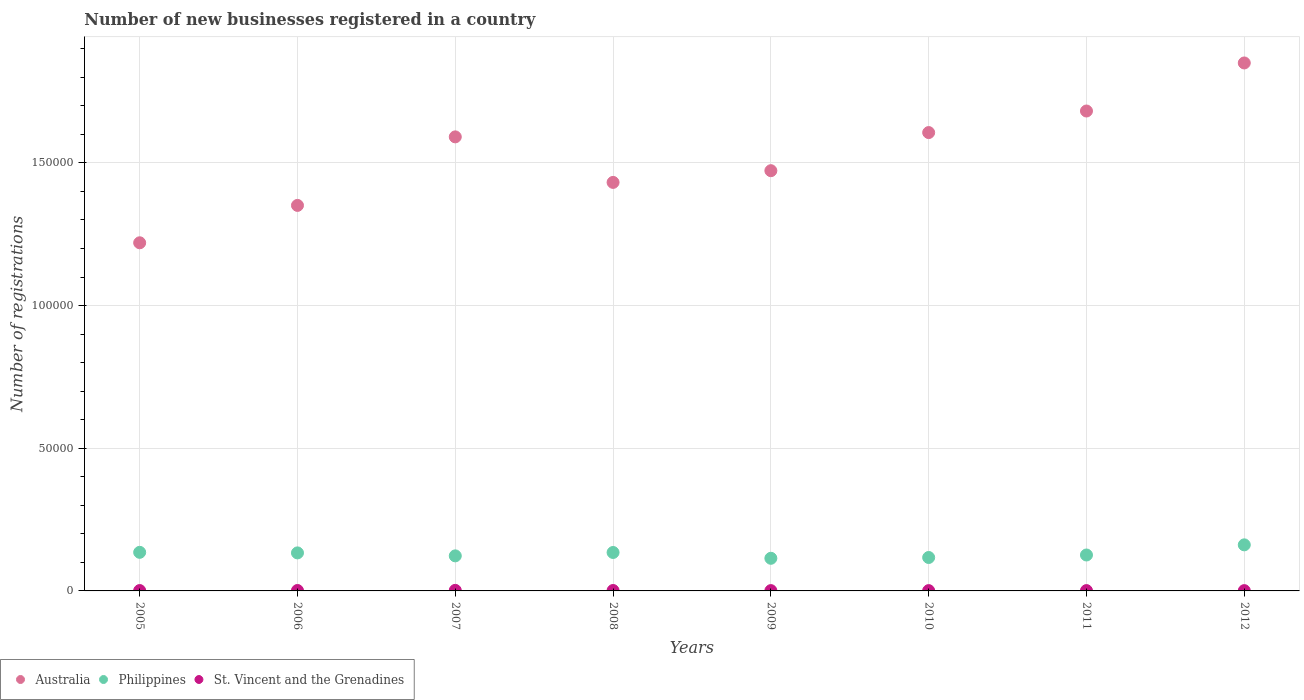What is the number of new businesses registered in Philippines in 2009?
Offer a very short reply. 1.14e+04. Across all years, what is the maximum number of new businesses registered in St. Vincent and the Grenadines?
Provide a succinct answer. 196. Across all years, what is the minimum number of new businesses registered in Australia?
Your answer should be very brief. 1.22e+05. What is the total number of new businesses registered in St. Vincent and the Grenadines in the graph?
Keep it short and to the point. 1047. What is the difference between the number of new businesses registered in St. Vincent and the Grenadines in 2005 and that in 2007?
Keep it short and to the point. -69. What is the difference between the number of new businesses registered in St. Vincent and the Grenadines in 2007 and the number of new businesses registered in Australia in 2012?
Give a very brief answer. -1.85e+05. What is the average number of new businesses registered in Philippines per year?
Your answer should be very brief. 1.31e+04. In the year 2012, what is the difference between the number of new businesses registered in St. Vincent and the Grenadines and number of new businesses registered in Australia?
Your answer should be very brief. -1.85e+05. In how many years, is the number of new businesses registered in Australia greater than 90000?
Ensure brevity in your answer.  8. What is the ratio of the number of new businesses registered in Philippines in 2005 to that in 2012?
Provide a succinct answer. 0.84. Is the number of new businesses registered in St. Vincent and the Grenadines in 2007 less than that in 2012?
Your answer should be very brief. No. What is the difference between the highest and the second highest number of new businesses registered in Australia?
Offer a terse response. 1.68e+04. What is the difference between the highest and the lowest number of new businesses registered in Australia?
Your answer should be compact. 6.30e+04. Is it the case that in every year, the sum of the number of new businesses registered in St. Vincent and the Grenadines and number of new businesses registered in Philippines  is greater than the number of new businesses registered in Australia?
Provide a succinct answer. No. Does the number of new businesses registered in St. Vincent and the Grenadines monotonically increase over the years?
Offer a terse response. No. How many years are there in the graph?
Offer a very short reply. 8. What is the difference between two consecutive major ticks on the Y-axis?
Ensure brevity in your answer.  5.00e+04. How many legend labels are there?
Offer a terse response. 3. How are the legend labels stacked?
Your answer should be very brief. Horizontal. What is the title of the graph?
Your answer should be very brief. Number of new businesses registered in a country. Does "Bangladesh" appear as one of the legend labels in the graph?
Make the answer very short. No. What is the label or title of the Y-axis?
Your answer should be compact. Number of registrations. What is the Number of registrations of Australia in 2005?
Your answer should be compact. 1.22e+05. What is the Number of registrations of Philippines in 2005?
Keep it short and to the point. 1.35e+04. What is the Number of registrations of St. Vincent and the Grenadines in 2005?
Keep it short and to the point. 127. What is the Number of registrations of Australia in 2006?
Give a very brief answer. 1.35e+05. What is the Number of registrations of Philippines in 2006?
Keep it short and to the point. 1.33e+04. What is the Number of registrations in St. Vincent and the Grenadines in 2006?
Make the answer very short. 149. What is the Number of registrations of Australia in 2007?
Your response must be concise. 1.59e+05. What is the Number of registrations in Philippines in 2007?
Provide a succinct answer. 1.23e+04. What is the Number of registrations of St. Vincent and the Grenadines in 2007?
Your response must be concise. 196. What is the Number of registrations in Australia in 2008?
Your answer should be very brief. 1.43e+05. What is the Number of registrations of Philippines in 2008?
Your answer should be very brief. 1.35e+04. What is the Number of registrations of St. Vincent and the Grenadines in 2008?
Your response must be concise. 145. What is the Number of registrations of Australia in 2009?
Your answer should be very brief. 1.47e+05. What is the Number of registrations in Philippines in 2009?
Give a very brief answer. 1.14e+04. What is the Number of registrations in St. Vincent and the Grenadines in 2009?
Provide a short and direct response. 109. What is the Number of registrations of Australia in 2010?
Your answer should be compact. 1.61e+05. What is the Number of registrations of Philippines in 2010?
Provide a short and direct response. 1.17e+04. What is the Number of registrations of St. Vincent and the Grenadines in 2010?
Your answer should be compact. 105. What is the Number of registrations of Australia in 2011?
Offer a terse response. 1.68e+05. What is the Number of registrations of Philippines in 2011?
Give a very brief answer. 1.26e+04. What is the Number of registrations of St. Vincent and the Grenadines in 2011?
Your answer should be compact. 115. What is the Number of registrations of Australia in 2012?
Provide a short and direct response. 1.85e+05. What is the Number of registrations of Philippines in 2012?
Make the answer very short. 1.61e+04. What is the Number of registrations in St. Vincent and the Grenadines in 2012?
Offer a terse response. 101. Across all years, what is the maximum Number of registrations of Australia?
Keep it short and to the point. 1.85e+05. Across all years, what is the maximum Number of registrations of Philippines?
Your response must be concise. 1.61e+04. Across all years, what is the maximum Number of registrations of St. Vincent and the Grenadines?
Your response must be concise. 196. Across all years, what is the minimum Number of registrations of Australia?
Offer a very short reply. 1.22e+05. Across all years, what is the minimum Number of registrations in Philippines?
Provide a short and direct response. 1.14e+04. Across all years, what is the minimum Number of registrations in St. Vincent and the Grenadines?
Your response must be concise. 101. What is the total Number of registrations of Australia in the graph?
Your answer should be compact. 1.22e+06. What is the total Number of registrations of Philippines in the graph?
Ensure brevity in your answer.  1.04e+05. What is the total Number of registrations in St. Vincent and the Grenadines in the graph?
Give a very brief answer. 1047. What is the difference between the Number of registrations of Australia in 2005 and that in 2006?
Your response must be concise. -1.31e+04. What is the difference between the Number of registrations of Philippines in 2005 and that in 2006?
Ensure brevity in your answer.  198. What is the difference between the Number of registrations of Australia in 2005 and that in 2007?
Provide a short and direct response. -3.71e+04. What is the difference between the Number of registrations in Philippines in 2005 and that in 2007?
Make the answer very short. 1238. What is the difference between the Number of registrations of St. Vincent and the Grenadines in 2005 and that in 2007?
Provide a short and direct response. -69. What is the difference between the Number of registrations in Australia in 2005 and that in 2008?
Your answer should be compact. -2.12e+04. What is the difference between the Number of registrations of Australia in 2005 and that in 2009?
Provide a short and direct response. -2.53e+04. What is the difference between the Number of registrations of Philippines in 2005 and that in 2009?
Provide a short and direct response. 2088. What is the difference between the Number of registrations of St. Vincent and the Grenadines in 2005 and that in 2009?
Your response must be concise. 18. What is the difference between the Number of registrations in Australia in 2005 and that in 2010?
Your answer should be compact. -3.86e+04. What is the difference between the Number of registrations in Philippines in 2005 and that in 2010?
Offer a very short reply. 1809. What is the difference between the Number of registrations in St. Vincent and the Grenadines in 2005 and that in 2010?
Keep it short and to the point. 22. What is the difference between the Number of registrations in Australia in 2005 and that in 2011?
Provide a succinct answer. -4.62e+04. What is the difference between the Number of registrations of Philippines in 2005 and that in 2011?
Offer a very short reply. 933. What is the difference between the Number of registrations in St. Vincent and the Grenadines in 2005 and that in 2011?
Keep it short and to the point. 12. What is the difference between the Number of registrations in Australia in 2005 and that in 2012?
Offer a terse response. -6.30e+04. What is the difference between the Number of registrations in Philippines in 2005 and that in 2012?
Provide a short and direct response. -2620. What is the difference between the Number of registrations of Australia in 2006 and that in 2007?
Ensure brevity in your answer.  -2.40e+04. What is the difference between the Number of registrations in Philippines in 2006 and that in 2007?
Ensure brevity in your answer.  1040. What is the difference between the Number of registrations of St. Vincent and the Grenadines in 2006 and that in 2007?
Your response must be concise. -47. What is the difference between the Number of registrations of Australia in 2006 and that in 2008?
Provide a succinct answer. -8061. What is the difference between the Number of registrations of Philippines in 2006 and that in 2008?
Ensure brevity in your answer.  -145. What is the difference between the Number of registrations in Australia in 2006 and that in 2009?
Provide a short and direct response. -1.22e+04. What is the difference between the Number of registrations of Philippines in 2006 and that in 2009?
Give a very brief answer. 1890. What is the difference between the Number of registrations of Australia in 2006 and that in 2010?
Your answer should be very brief. -2.55e+04. What is the difference between the Number of registrations in Philippines in 2006 and that in 2010?
Your answer should be very brief. 1611. What is the difference between the Number of registrations of St. Vincent and the Grenadines in 2006 and that in 2010?
Your response must be concise. 44. What is the difference between the Number of registrations of Australia in 2006 and that in 2011?
Give a very brief answer. -3.31e+04. What is the difference between the Number of registrations in Philippines in 2006 and that in 2011?
Your response must be concise. 735. What is the difference between the Number of registrations of Australia in 2006 and that in 2012?
Offer a very short reply. -4.99e+04. What is the difference between the Number of registrations in Philippines in 2006 and that in 2012?
Make the answer very short. -2818. What is the difference between the Number of registrations in Australia in 2007 and that in 2008?
Ensure brevity in your answer.  1.60e+04. What is the difference between the Number of registrations in Philippines in 2007 and that in 2008?
Make the answer very short. -1185. What is the difference between the Number of registrations of St. Vincent and the Grenadines in 2007 and that in 2008?
Give a very brief answer. 51. What is the difference between the Number of registrations of Australia in 2007 and that in 2009?
Provide a succinct answer. 1.18e+04. What is the difference between the Number of registrations in Philippines in 2007 and that in 2009?
Make the answer very short. 850. What is the difference between the Number of registrations of St. Vincent and the Grenadines in 2007 and that in 2009?
Provide a short and direct response. 87. What is the difference between the Number of registrations of Australia in 2007 and that in 2010?
Give a very brief answer. -1507. What is the difference between the Number of registrations of Philippines in 2007 and that in 2010?
Offer a very short reply. 571. What is the difference between the Number of registrations of St. Vincent and the Grenadines in 2007 and that in 2010?
Your answer should be very brief. 91. What is the difference between the Number of registrations in Australia in 2007 and that in 2011?
Provide a succinct answer. -9062. What is the difference between the Number of registrations of Philippines in 2007 and that in 2011?
Your response must be concise. -305. What is the difference between the Number of registrations of Australia in 2007 and that in 2012?
Offer a very short reply. -2.59e+04. What is the difference between the Number of registrations of Philippines in 2007 and that in 2012?
Provide a succinct answer. -3858. What is the difference between the Number of registrations in St. Vincent and the Grenadines in 2007 and that in 2012?
Your answer should be compact. 95. What is the difference between the Number of registrations in Australia in 2008 and that in 2009?
Your answer should be compact. -4105. What is the difference between the Number of registrations of Philippines in 2008 and that in 2009?
Offer a very short reply. 2035. What is the difference between the Number of registrations in Australia in 2008 and that in 2010?
Ensure brevity in your answer.  -1.75e+04. What is the difference between the Number of registrations in Philippines in 2008 and that in 2010?
Offer a terse response. 1756. What is the difference between the Number of registrations of Australia in 2008 and that in 2011?
Provide a short and direct response. -2.50e+04. What is the difference between the Number of registrations of Philippines in 2008 and that in 2011?
Your response must be concise. 880. What is the difference between the Number of registrations of St. Vincent and the Grenadines in 2008 and that in 2011?
Offer a terse response. 30. What is the difference between the Number of registrations of Australia in 2008 and that in 2012?
Your answer should be compact. -4.19e+04. What is the difference between the Number of registrations of Philippines in 2008 and that in 2012?
Make the answer very short. -2673. What is the difference between the Number of registrations in St. Vincent and the Grenadines in 2008 and that in 2012?
Keep it short and to the point. 44. What is the difference between the Number of registrations of Australia in 2009 and that in 2010?
Your answer should be compact. -1.34e+04. What is the difference between the Number of registrations in Philippines in 2009 and that in 2010?
Your answer should be very brief. -279. What is the difference between the Number of registrations of Australia in 2009 and that in 2011?
Ensure brevity in your answer.  -2.09e+04. What is the difference between the Number of registrations of Philippines in 2009 and that in 2011?
Provide a short and direct response. -1155. What is the difference between the Number of registrations of Australia in 2009 and that in 2012?
Give a very brief answer. -3.78e+04. What is the difference between the Number of registrations in Philippines in 2009 and that in 2012?
Provide a succinct answer. -4708. What is the difference between the Number of registrations in St. Vincent and the Grenadines in 2009 and that in 2012?
Offer a terse response. 8. What is the difference between the Number of registrations of Australia in 2010 and that in 2011?
Your response must be concise. -7555. What is the difference between the Number of registrations of Philippines in 2010 and that in 2011?
Your answer should be compact. -876. What is the difference between the Number of registrations in St. Vincent and the Grenadines in 2010 and that in 2011?
Ensure brevity in your answer.  -10. What is the difference between the Number of registrations in Australia in 2010 and that in 2012?
Offer a very short reply. -2.44e+04. What is the difference between the Number of registrations of Philippines in 2010 and that in 2012?
Your response must be concise. -4429. What is the difference between the Number of registrations of St. Vincent and the Grenadines in 2010 and that in 2012?
Provide a short and direct response. 4. What is the difference between the Number of registrations in Australia in 2011 and that in 2012?
Your answer should be very brief. -1.68e+04. What is the difference between the Number of registrations in Philippines in 2011 and that in 2012?
Your answer should be very brief. -3553. What is the difference between the Number of registrations of St. Vincent and the Grenadines in 2011 and that in 2012?
Provide a succinct answer. 14. What is the difference between the Number of registrations of Australia in 2005 and the Number of registrations of Philippines in 2006?
Make the answer very short. 1.09e+05. What is the difference between the Number of registrations of Australia in 2005 and the Number of registrations of St. Vincent and the Grenadines in 2006?
Your answer should be very brief. 1.22e+05. What is the difference between the Number of registrations in Philippines in 2005 and the Number of registrations in St. Vincent and the Grenadines in 2006?
Offer a very short reply. 1.34e+04. What is the difference between the Number of registrations in Australia in 2005 and the Number of registrations in Philippines in 2007?
Offer a terse response. 1.10e+05. What is the difference between the Number of registrations in Australia in 2005 and the Number of registrations in St. Vincent and the Grenadines in 2007?
Offer a very short reply. 1.22e+05. What is the difference between the Number of registrations of Philippines in 2005 and the Number of registrations of St. Vincent and the Grenadines in 2007?
Your answer should be very brief. 1.33e+04. What is the difference between the Number of registrations in Australia in 2005 and the Number of registrations in Philippines in 2008?
Offer a terse response. 1.09e+05. What is the difference between the Number of registrations of Australia in 2005 and the Number of registrations of St. Vincent and the Grenadines in 2008?
Keep it short and to the point. 1.22e+05. What is the difference between the Number of registrations of Philippines in 2005 and the Number of registrations of St. Vincent and the Grenadines in 2008?
Ensure brevity in your answer.  1.34e+04. What is the difference between the Number of registrations of Australia in 2005 and the Number of registrations of Philippines in 2009?
Offer a very short reply. 1.11e+05. What is the difference between the Number of registrations in Australia in 2005 and the Number of registrations in St. Vincent and the Grenadines in 2009?
Your answer should be very brief. 1.22e+05. What is the difference between the Number of registrations in Philippines in 2005 and the Number of registrations in St. Vincent and the Grenadines in 2009?
Your response must be concise. 1.34e+04. What is the difference between the Number of registrations of Australia in 2005 and the Number of registrations of Philippines in 2010?
Keep it short and to the point. 1.10e+05. What is the difference between the Number of registrations in Australia in 2005 and the Number of registrations in St. Vincent and the Grenadines in 2010?
Provide a succinct answer. 1.22e+05. What is the difference between the Number of registrations of Philippines in 2005 and the Number of registrations of St. Vincent and the Grenadines in 2010?
Ensure brevity in your answer.  1.34e+04. What is the difference between the Number of registrations in Australia in 2005 and the Number of registrations in Philippines in 2011?
Keep it short and to the point. 1.09e+05. What is the difference between the Number of registrations of Australia in 2005 and the Number of registrations of St. Vincent and the Grenadines in 2011?
Ensure brevity in your answer.  1.22e+05. What is the difference between the Number of registrations of Philippines in 2005 and the Number of registrations of St. Vincent and the Grenadines in 2011?
Make the answer very short. 1.34e+04. What is the difference between the Number of registrations in Australia in 2005 and the Number of registrations in Philippines in 2012?
Make the answer very short. 1.06e+05. What is the difference between the Number of registrations of Australia in 2005 and the Number of registrations of St. Vincent and the Grenadines in 2012?
Your answer should be compact. 1.22e+05. What is the difference between the Number of registrations in Philippines in 2005 and the Number of registrations in St. Vincent and the Grenadines in 2012?
Offer a very short reply. 1.34e+04. What is the difference between the Number of registrations of Australia in 2006 and the Number of registrations of Philippines in 2007?
Your answer should be very brief. 1.23e+05. What is the difference between the Number of registrations of Australia in 2006 and the Number of registrations of St. Vincent and the Grenadines in 2007?
Provide a short and direct response. 1.35e+05. What is the difference between the Number of registrations in Philippines in 2006 and the Number of registrations in St. Vincent and the Grenadines in 2007?
Give a very brief answer. 1.31e+04. What is the difference between the Number of registrations in Australia in 2006 and the Number of registrations in Philippines in 2008?
Your response must be concise. 1.22e+05. What is the difference between the Number of registrations of Australia in 2006 and the Number of registrations of St. Vincent and the Grenadines in 2008?
Provide a succinct answer. 1.35e+05. What is the difference between the Number of registrations in Philippines in 2006 and the Number of registrations in St. Vincent and the Grenadines in 2008?
Provide a succinct answer. 1.32e+04. What is the difference between the Number of registrations in Australia in 2006 and the Number of registrations in Philippines in 2009?
Provide a succinct answer. 1.24e+05. What is the difference between the Number of registrations in Australia in 2006 and the Number of registrations in St. Vincent and the Grenadines in 2009?
Provide a succinct answer. 1.35e+05. What is the difference between the Number of registrations in Philippines in 2006 and the Number of registrations in St. Vincent and the Grenadines in 2009?
Make the answer very short. 1.32e+04. What is the difference between the Number of registrations in Australia in 2006 and the Number of registrations in Philippines in 2010?
Your answer should be compact. 1.23e+05. What is the difference between the Number of registrations of Australia in 2006 and the Number of registrations of St. Vincent and the Grenadines in 2010?
Your response must be concise. 1.35e+05. What is the difference between the Number of registrations in Philippines in 2006 and the Number of registrations in St. Vincent and the Grenadines in 2010?
Ensure brevity in your answer.  1.32e+04. What is the difference between the Number of registrations in Australia in 2006 and the Number of registrations in Philippines in 2011?
Make the answer very short. 1.23e+05. What is the difference between the Number of registrations in Australia in 2006 and the Number of registrations in St. Vincent and the Grenadines in 2011?
Offer a terse response. 1.35e+05. What is the difference between the Number of registrations of Philippines in 2006 and the Number of registrations of St. Vincent and the Grenadines in 2011?
Give a very brief answer. 1.32e+04. What is the difference between the Number of registrations of Australia in 2006 and the Number of registrations of Philippines in 2012?
Keep it short and to the point. 1.19e+05. What is the difference between the Number of registrations in Australia in 2006 and the Number of registrations in St. Vincent and the Grenadines in 2012?
Provide a short and direct response. 1.35e+05. What is the difference between the Number of registrations of Philippines in 2006 and the Number of registrations of St. Vincent and the Grenadines in 2012?
Ensure brevity in your answer.  1.32e+04. What is the difference between the Number of registrations in Australia in 2007 and the Number of registrations in Philippines in 2008?
Keep it short and to the point. 1.46e+05. What is the difference between the Number of registrations of Australia in 2007 and the Number of registrations of St. Vincent and the Grenadines in 2008?
Provide a succinct answer. 1.59e+05. What is the difference between the Number of registrations of Philippines in 2007 and the Number of registrations of St. Vincent and the Grenadines in 2008?
Your answer should be compact. 1.21e+04. What is the difference between the Number of registrations of Australia in 2007 and the Number of registrations of Philippines in 2009?
Your answer should be very brief. 1.48e+05. What is the difference between the Number of registrations of Australia in 2007 and the Number of registrations of St. Vincent and the Grenadines in 2009?
Give a very brief answer. 1.59e+05. What is the difference between the Number of registrations of Philippines in 2007 and the Number of registrations of St. Vincent and the Grenadines in 2009?
Your response must be concise. 1.22e+04. What is the difference between the Number of registrations in Australia in 2007 and the Number of registrations in Philippines in 2010?
Offer a terse response. 1.47e+05. What is the difference between the Number of registrations of Australia in 2007 and the Number of registrations of St. Vincent and the Grenadines in 2010?
Give a very brief answer. 1.59e+05. What is the difference between the Number of registrations of Philippines in 2007 and the Number of registrations of St. Vincent and the Grenadines in 2010?
Provide a succinct answer. 1.22e+04. What is the difference between the Number of registrations of Australia in 2007 and the Number of registrations of Philippines in 2011?
Provide a short and direct response. 1.47e+05. What is the difference between the Number of registrations of Australia in 2007 and the Number of registrations of St. Vincent and the Grenadines in 2011?
Provide a succinct answer. 1.59e+05. What is the difference between the Number of registrations of Philippines in 2007 and the Number of registrations of St. Vincent and the Grenadines in 2011?
Offer a very short reply. 1.22e+04. What is the difference between the Number of registrations in Australia in 2007 and the Number of registrations in Philippines in 2012?
Offer a very short reply. 1.43e+05. What is the difference between the Number of registrations of Australia in 2007 and the Number of registrations of St. Vincent and the Grenadines in 2012?
Ensure brevity in your answer.  1.59e+05. What is the difference between the Number of registrations in Philippines in 2007 and the Number of registrations in St. Vincent and the Grenadines in 2012?
Your answer should be compact. 1.22e+04. What is the difference between the Number of registrations in Australia in 2008 and the Number of registrations in Philippines in 2009?
Provide a succinct answer. 1.32e+05. What is the difference between the Number of registrations of Australia in 2008 and the Number of registrations of St. Vincent and the Grenadines in 2009?
Provide a succinct answer. 1.43e+05. What is the difference between the Number of registrations in Philippines in 2008 and the Number of registrations in St. Vincent and the Grenadines in 2009?
Provide a short and direct response. 1.34e+04. What is the difference between the Number of registrations of Australia in 2008 and the Number of registrations of Philippines in 2010?
Your answer should be compact. 1.31e+05. What is the difference between the Number of registrations of Australia in 2008 and the Number of registrations of St. Vincent and the Grenadines in 2010?
Offer a very short reply. 1.43e+05. What is the difference between the Number of registrations of Philippines in 2008 and the Number of registrations of St. Vincent and the Grenadines in 2010?
Keep it short and to the point. 1.34e+04. What is the difference between the Number of registrations in Australia in 2008 and the Number of registrations in Philippines in 2011?
Provide a succinct answer. 1.31e+05. What is the difference between the Number of registrations in Australia in 2008 and the Number of registrations in St. Vincent and the Grenadines in 2011?
Make the answer very short. 1.43e+05. What is the difference between the Number of registrations in Philippines in 2008 and the Number of registrations in St. Vincent and the Grenadines in 2011?
Ensure brevity in your answer.  1.34e+04. What is the difference between the Number of registrations in Australia in 2008 and the Number of registrations in Philippines in 2012?
Give a very brief answer. 1.27e+05. What is the difference between the Number of registrations in Australia in 2008 and the Number of registrations in St. Vincent and the Grenadines in 2012?
Keep it short and to the point. 1.43e+05. What is the difference between the Number of registrations of Philippines in 2008 and the Number of registrations of St. Vincent and the Grenadines in 2012?
Ensure brevity in your answer.  1.34e+04. What is the difference between the Number of registrations in Australia in 2009 and the Number of registrations in Philippines in 2010?
Ensure brevity in your answer.  1.36e+05. What is the difference between the Number of registrations of Australia in 2009 and the Number of registrations of St. Vincent and the Grenadines in 2010?
Keep it short and to the point. 1.47e+05. What is the difference between the Number of registrations in Philippines in 2009 and the Number of registrations in St. Vincent and the Grenadines in 2010?
Give a very brief answer. 1.13e+04. What is the difference between the Number of registrations of Australia in 2009 and the Number of registrations of Philippines in 2011?
Provide a short and direct response. 1.35e+05. What is the difference between the Number of registrations of Australia in 2009 and the Number of registrations of St. Vincent and the Grenadines in 2011?
Provide a short and direct response. 1.47e+05. What is the difference between the Number of registrations of Philippines in 2009 and the Number of registrations of St. Vincent and the Grenadines in 2011?
Give a very brief answer. 1.13e+04. What is the difference between the Number of registrations in Australia in 2009 and the Number of registrations in Philippines in 2012?
Provide a succinct answer. 1.31e+05. What is the difference between the Number of registrations in Australia in 2009 and the Number of registrations in St. Vincent and the Grenadines in 2012?
Provide a short and direct response. 1.47e+05. What is the difference between the Number of registrations of Philippines in 2009 and the Number of registrations of St. Vincent and the Grenadines in 2012?
Offer a very short reply. 1.13e+04. What is the difference between the Number of registrations in Australia in 2010 and the Number of registrations in Philippines in 2011?
Your answer should be very brief. 1.48e+05. What is the difference between the Number of registrations in Australia in 2010 and the Number of registrations in St. Vincent and the Grenadines in 2011?
Keep it short and to the point. 1.60e+05. What is the difference between the Number of registrations in Philippines in 2010 and the Number of registrations in St. Vincent and the Grenadines in 2011?
Provide a short and direct response. 1.16e+04. What is the difference between the Number of registrations of Australia in 2010 and the Number of registrations of Philippines in 2012?
Provide a succinct answer. 1.44e+05. What is the difference between the Number of registrations in Australia in 2010 and the Number of registrations in St. Vincent and the Grenadines in 2012?
Offer a terse response. 1.61e+05. What is the difference between the Number of registrations of Philippines in 2010 and the Number of registrations of St. Vincent and the Grenadines in 2012?
Ensure brevity in your answer.  1.16e+04. What is the difference between the Number of registrations of Australia in 2011 and the Number of registrations of Philippines in 2012?
Your answer should be compact. 1.52e+05. What is the difference between the Number of registrations of Australia in 2011 and the Number of registrations of St. Vincent and the Grenadines in 2012?
Give a very brief answer. 1.68e+05. What is the difference between the Number of registrations of Philippines in 2011 and the Number of registrations of St. Vincent and the Grenadines in 2012?
Make the answer very short. 1.25e+04. What is the average Number of registrations of Australia per year?
Provide a short and direct response. 1.53e+05. What is the average Number of registrations of Philippines per year?
Make the answer very short. 1.31e+04. What is the average Number of registrations in St. Vincent and the Grenadines per year?
Offer a very short reply. 130.88. In the year 2005, what is the difference between the Number of registrations in Australia and Number of registrations in Philippines?
Offer a very short reply. 1.08e+05. In the year 2005, what is the difference between the Number of registrations in Australia and Number of registrations in St. Vincent and the Grenadines?
Provide a succinct answer. 1.22e+05. In the year 2005, what is the difference between the Number of registrations in Philippines and Number of registrations in St. Vincent and the Grenadines?
Provide a short and direct response. 1.34e+04. In the year 2006, what is the difference between the Number of registrations in Australia and Number of registrations in Philippines?
Make the answer very short. 1.22e+05. In the year 2006, what is the difference between the Number of registrations of Australia and Number of registrations of St. Vincent and the Grenadines?
Make the answer very short. 1.35e+05. In the year 2006, what is the difference between the Number of registrations of Philippines and Number of registrations of St. Vincent and the Grenadines?
Your response must be concise. 1.32e+04. In the year 2007, what is the difference between the Number of registrations of Australia and Number of registrations of Philippines?
Ensure brevity in your answer.  1.47e+05. In the year 2007, what is the difference between the Number of registrations of Australia and Number of registrations of St. Vincent and the Grenadines?
Offer a very short reply. 1.59e+05. In the year 2007, what is the difference between the Number of registrations of Philippines and Number of registrations of St. Vincent and the Grenadines?
Offer a very short reply. 1.21e+04. In the year 2008, what is the difference between the Number of registrations of Australia and Number of registrations of Philippines?
Keep it short and to the point. 1.30e+05. In the year 2008, what is the difference between the Number of registrations in Australia and Number of registrations in St. Vincent and the Grenadines?
Provide a succinct answer. 1.43e+05. In the year 2008, what is the difference between the Number of registrations of Philippines and Number of registrations of St. Vincent and the Grenadines?
Provide a short and direct response. 1.33e+04. In the year 2009, what is the difference between the Number of registrations in Australia and Number of registrations in Philippines?
Your response must be concise. 1.36e+05. In the year 2009, what is the difference between the Number of registrations of Australia and Number of registrations of St. Vincent and the Grenadines?
Your answer should be compact. 1.47e+05. In the year 2009, what is the difference between the Number of registrations in Philippines and Number of registrations in St. Vincent and the Grenadines?
Your answer should be compact. 1.13e+04. In the year 2010, what is the difference between the Number of registrations in Australia and Number of registrations in Philippines?
Give a very brief answer. 1.49e+05. In the year 2010, what is the difference between the Number of registrations in Australia and Number of registrations in St. Vincent and the Grenadines?
Your answer should be very brief. 1.61e+05. In the year 2010, what is the difference between the Number of registrations of Philippines and Number of registrations of St. Vincent and the Grenadines?
Your answer should be compact. 1.16e+04. In the year 2011, what is the difference between the Number of registrations in Australia and Number of registrations in Philippines?
Provide a short and direct response. 1.56e+05. In the year 2011, what is the difference between the Number of registrations in Australia and Number of registrations in St. Vincent and the Grenadines?
Your response must be concise. 1.68e+05. In the year 2011, what is the difference between the Number of registrations in Philippines and Number of registrations in St. Vincent and the Grenadines?
Make the answer very short. 1.25e+04. In the year 2012, what is the difference between the Number of registrations in Australia and Number of registrations in Philippines?
Ensure brevity in your answer.  1.69e+05. In the year 2012, what is the difference between the Number of registrations of Australia and Number of registrations of St. Vincent and the Grenadines?
Give a very brief answer. 1.85e+05. In the year 2012, what is the difference between the Number of registrations of Philippines and Number of registrations of St. Vincent and the Grenadines?
Provide a succinct answer. 1.60e+04. What is the ratio of the Number of registrations of Australia in 2005 to that in 2006?
Your response must be concise. 0.9. What is the ratio of the Number of registrations of Philippines in 2005 to that in 2006?
Your answer should be very brief. 1.01. What is the ratio of the Number of registrations of St. Vincent and the Grenadines in 2005 to that in 2006?
Ensure brevity in your answer.  0.85. What is the ratio of the Number of registrations in Australia in 2005 to that in 2007?
Your answer should be very brief. 0.77. What is the ratio of the Number of registrations of Philippines in 2005 to that in 2007?
Offer a terse response. 1.1. What is the ratio of the Number of registrations in St. Vincent and the Grenadines in 2005 to that in 2007?
Your answer should be compact. 0.65. What is the ratio of the Number of registrations of Australia in 2005 to that in 2008?
Provide a succinct answer. 0.85. What is the ratio of the Number of registrations in Philippines in 2005 to that in 2008?
Provide a short and direct response. 1. What is the ratio of the Number of registrations in St. Vincent and the Grenadines in 2005 to that in 2008?
Keep it short and to the point. 0.88. What is the ratio of the Number of registrations of Australia in 2005 to that in 2009?
Your response must be concise. 0.83. What is the ratio of the Number of registrations in Philippines in 2005 to that in 2009?
Provide a short and direct response. 1.18. What is the ratio of the Number of registrations of St. Vincent and the Grenadines in 2005 to that in 2009?
Your answer should be compact. 1.17. What is the ratio of the Number of registrations of Australia in 2005 to that in 2010?
Offer a very short reply. 0.76. What is the ratio of the Number of registrations of Philippines in 2005 to that in 2010?
Make the answer very short. 1.15. What is the ratio of the Number of registrations in St. Vincent and the Grenadines in 2005 to that in 2010?
Provide a short and direct response. 1.21. What is the ratio of the Number of registrations in Australia in 2005 to that in 2011?
Offer a very short reply. 0.73. What is the ratio of the Number of registrations of Philippines in 2005 to that in 2011?
Your answer should be very brief. 1.07. What is the ratio of the Number of registrations in St. Vincent and the Grenadines in 2005 to that in 2011?
Keep it short and to the point. 1.1. What is the ratio of the Number of registrations of Australia in 2005 to that in 2012?
Provide a short and direct response. 0.66. What is the ratio of the Number of registrations in Philippines in 2005 to that in 2012?
Offer a terse response. 0.84. What is the ratio of the Number of registrations of St. Vincent and the Grenadines in 2005 to that in 2012?
Ensure brevity in your answer.  1.26. What is the ratio of the Number of registrations in Australia in 2006 to that in 2007?
Give a very brief answer. 0.85. What is the ratio of the Number of registrations in Philippines in 2006 to that in 2007?
Provide a succinct answer. 1.08. What is the ratio of the Number of registrations in St. Vincent and the Grenadines in 2006 to that in 2007?
Give a very brief answer. 0.76. What is the ratio of the Number of registrations of Australia in 2006 to that in 2008?
Offer a terse response. 0.94. What is the ratio of the Number of registrations of St. Vincent and the Grenadines in 2006 to that in 2008?
Ensure brevity in your answer.  1.03. What is the ratio of the Number of registrations of Australia in 2006 to that in 2009?
Offer a terse response. 0.92. What is the ratio of the Number of registrations of Philippines in 2006 to that in 2009?
Your answer should be compact. 1.17. What is the ratio of the Number of registrations in St. Vincent and the Grenadines in 2006 to that in 2009?
Offer a terse response. 1.37. What is the ratio of the Number of registrations in Australia in 2006 to that in 2010?
Your answer should be compact. 0.84. What is the ratio of the Number of registrations of Philippines in 2006 to that in 2010?
Your response must be concise. 1.14. What is the ratio of the Number of registrations in St. Vincent and the Grenadines in 2006 to that in 2010?
Your answer should be very brief. 1.42. What is the ratio of the Number of registrations in Australia in 2006 to that in 2011?
Your answer should be compact. 0.8. What is the ratio of the Number of registrations of Philippines in 2006 to that in 2011?
Your answer should be compact. 1.06. What is the ratio of the Number of registrations of St. Vincent and the Grenadines in 2006 to that in 2011?
Provide a succinct answer. 1.3. What is the ratio of the Number of registrations in Australia in 2006 to that in 2012?
Your answer should be compact. 0.73. What is the ratio of the Number of registrations in Philippines in 2006 to that in 2012?
Ensure brevity in your answer.  0.83. What is the ratio of the Number of registrations of St. Vincent and the Grenadines in 2006 to that in 2012?
Ensure brevity in your answer.  1.48. What is the ratio of the Number of registrations in Australia in 2007 to that in 2008?
Provide a short and direct response. 1.11. What is the ratio of the Number of registrations in Philippines in 2007 to that in 2008?
Your answer should be very brief. 0.91. What is the ratio of the Number of registrations of St. Vincent and the Grenadines in 2007 to that in 2008?
Keep it short and to the point. 1.35. What is the ratio of the Number of registrations in Australia in 2007 to that in 2009?
Provide a succinct answer. 1.08. What is the ratio of the Number of registrations in Philippines in 2007 to that in 2009?
Offer a very short reply. 1.07. What is the ratio of the Number of registrations of St. Vincent and the Grenadines in 2007 to that in 2009?
Provide a succinct answer. 1.8. What is the ratio of the Number of registrations in Australia in 2007 to that in 2010?
Your answer should be compact. 0.99. What is the ratio of the Number of registrations in Philippines in 2007 to that in 2010?
Ensure brevity in your answer.  1.05. What is the ratio of the Number of registrations in St. Vincent and the Grenadines in 2007 to that in 2010?
Your answer should be compact. 1.87. What is the ratio of the Number of registrations of Australia in 2007 to that in 2011?
Provide a short and direct response. 0.95. What is the ratio of the Number of registrations in Philippines in 2007 to that in 2011?
Your response must be concise. 0.98. What is the ratio of the Number of registrations of St. Vincent and the Grenadines in 2007 to that in 2011?
Offer a terse response. 1.7. What is the ratio of the Number of registrations of Australia in 2007 to that in 2012?
Your answer should be very brief. 0.86. What is the ratio of the Number of registrations of Philippines in 2007 to that in 2012?
Provide a succinct answer. 0.76. What is the ratio of the Number of registrations of St. Vincent and the Grenadines in 2007 to that in 2012?
Your response must be concise. 1.94. What is the ratio of the Number of registrations in Australia in 2008 to that in 2009?
Provide a short and direct response. 0.97. What is the ratio of the Number of registrations in Philippines in 2008 to that in 2009?
Ensure brevity in your answer.  1.18. What is the ratio of the Number of registrations of St. Vincent and the Grenadines in 2008 to that in 2009?
Your answer should be compact. 1.33. What is the ratio of the Number of registrations of Australia in 2008 to that in 2010?
Offer a very short reply. 0.89. What is the ratio of the Number of registrations in Philippines in 2008 to that in 2010?
Ensure brevity in your answer.  1.15. What is the ratio of the Number of registrations in St. Vincent and the Grenadines in 2008 to that in 2010?
Give a very brief answer. 1.38. What is the ratio of the Number of registrations of Australia in 2008 to that in 2011?
Your answer should be very brief. 0.85. What is the ratio of the Number of registrations in Philippines in 2008 to that in 2011?
Provide a succinct answer. 1.07. What is the ratio of the Number of registrations of St. Vincent and the Grenadines in 2008 to that in 2011?
Provide a short and direct response. 1.26. What is the ratio of the Number of registrations of Australia in 2008 to that in 2012?
Your answer should be compact. 0.77. What is the ratio of the Number of registrations of Philippines in 2008 to that in 2012?
Keep it short and to the point. 0.83. What is the ratio of the Number of registrations of St. Vincent and the Grenadines in 2008 to that in 2012?
Your answer should be very brief. 1.44. What is the ratio of the Number of registrations of Australia in 2009 to that in 2010?
Offer a terse response. 0.92. What is the ratio of the Number of registrations in Philippines in 2009 to that in 2010?
Make the answer very short. 0.98. What is the ratio of the Number of registrations of St. Vincent and the Grenadines in 2009 to that in 2010?
Keep it short and to the point. 1.04. What is the ratio of the Number of registrations in Australia in 2009 to that in 2011?
Offer a very short reply. 0.88. What is the ratio of the Number of registrations of Philippines in 2009 to that in 2011?
Keep it short and to the point. 0.91. What is the ratio of the Number of registrations of St. Vincent and the Grenadines in 2009 to that in 2011?
Offer a terse response. 0.95. What is the ratio of the Number of registrations of Australia in 2009 to that in 2012?
Make the answer very short. 0.8. What is the ratio of the Number of registrations of Philippines in 2009 to that in 2012?
Provide a short and direct response. 0.71. What is the ratio of the Number of registrations of St. Vincent and the Grenadines in 2009 to that in 2012?
Make the answer very short. 1.08. What is the ratio of the Number of registrations in Australia in 2010 to that in 2011?
Your answer should be compact. 0.96. What is the ratio of the Number of registrations of Philippines in 2010 to that in 2011?
Give a very brief answer. 0.93. What is the ratio of the Number of registrations in Australia in 2010 to that in 2012?
Give a very brief answer. 0.87. What is the ratio of the Number of registrations in Philippines in 2010 to that in 2012?
Offer a very short reply. 0.73. What is the ratio of the Number of registrations in St. Vincent and the Grenadines in 2010 to that in 2012?
Your response must be concise. 1.04. What is the ratio of the Number of registrations of Australia in 2011 to that in 2012?
Offer a terse response. 0.91. What is the ratio of the Number of registrations of Philippines in 2011 to that in 2012?
Offer a very short reply. 0.78. What is the ratio of the Number of registrations of St. Vincent and the Grenadines in 2011 to that in 2012?
Your response must be concise. 1.14. What is the difference between the highest and the second highest Number of registrations in Australia?
Provide a short and direct response. 1.68e+04. What is the difference between the highest and the second highest Number of registrations of Philippines?
Your answer should be compact. 2620. What is the difference between the highest and the second highest Number of registrations in St. Vincent and the Grenadines?
Your response must be concise. 47. What is the difference between the highest and the lowest Number of registrations in Australia?
Provide a short and direct response. 6.30e+04. What is the difference between the highest and the lowest Number of registrations of Philippines?
Ensure brevity in your answer.  4708. What is the difference between the highest and the lowest Number of registrations of St. Vincent and the Grenadines?
Give a very brief answer. 95. 